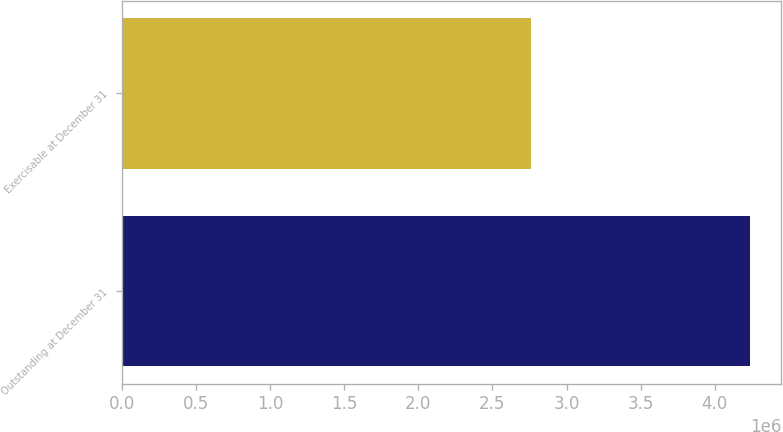<chart> <loc_0><loc_0><loc_500><loc_500><bar_chart><fcel>Outstanding at December 31<fcel>Exercisable at December 31<nl><fcel>4.238e+06<fcel>2.763e+06<nl></chart> 